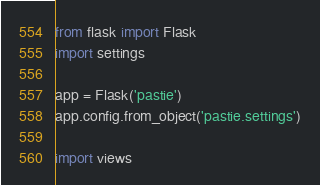Convert code to text. <code><loc_0><loc_0><loc_500><loc_500><_Python_>from flask import Flask
import settings

app = Flask('pastie')
app.config.from_object('pastie.settings')

import views
</code> 